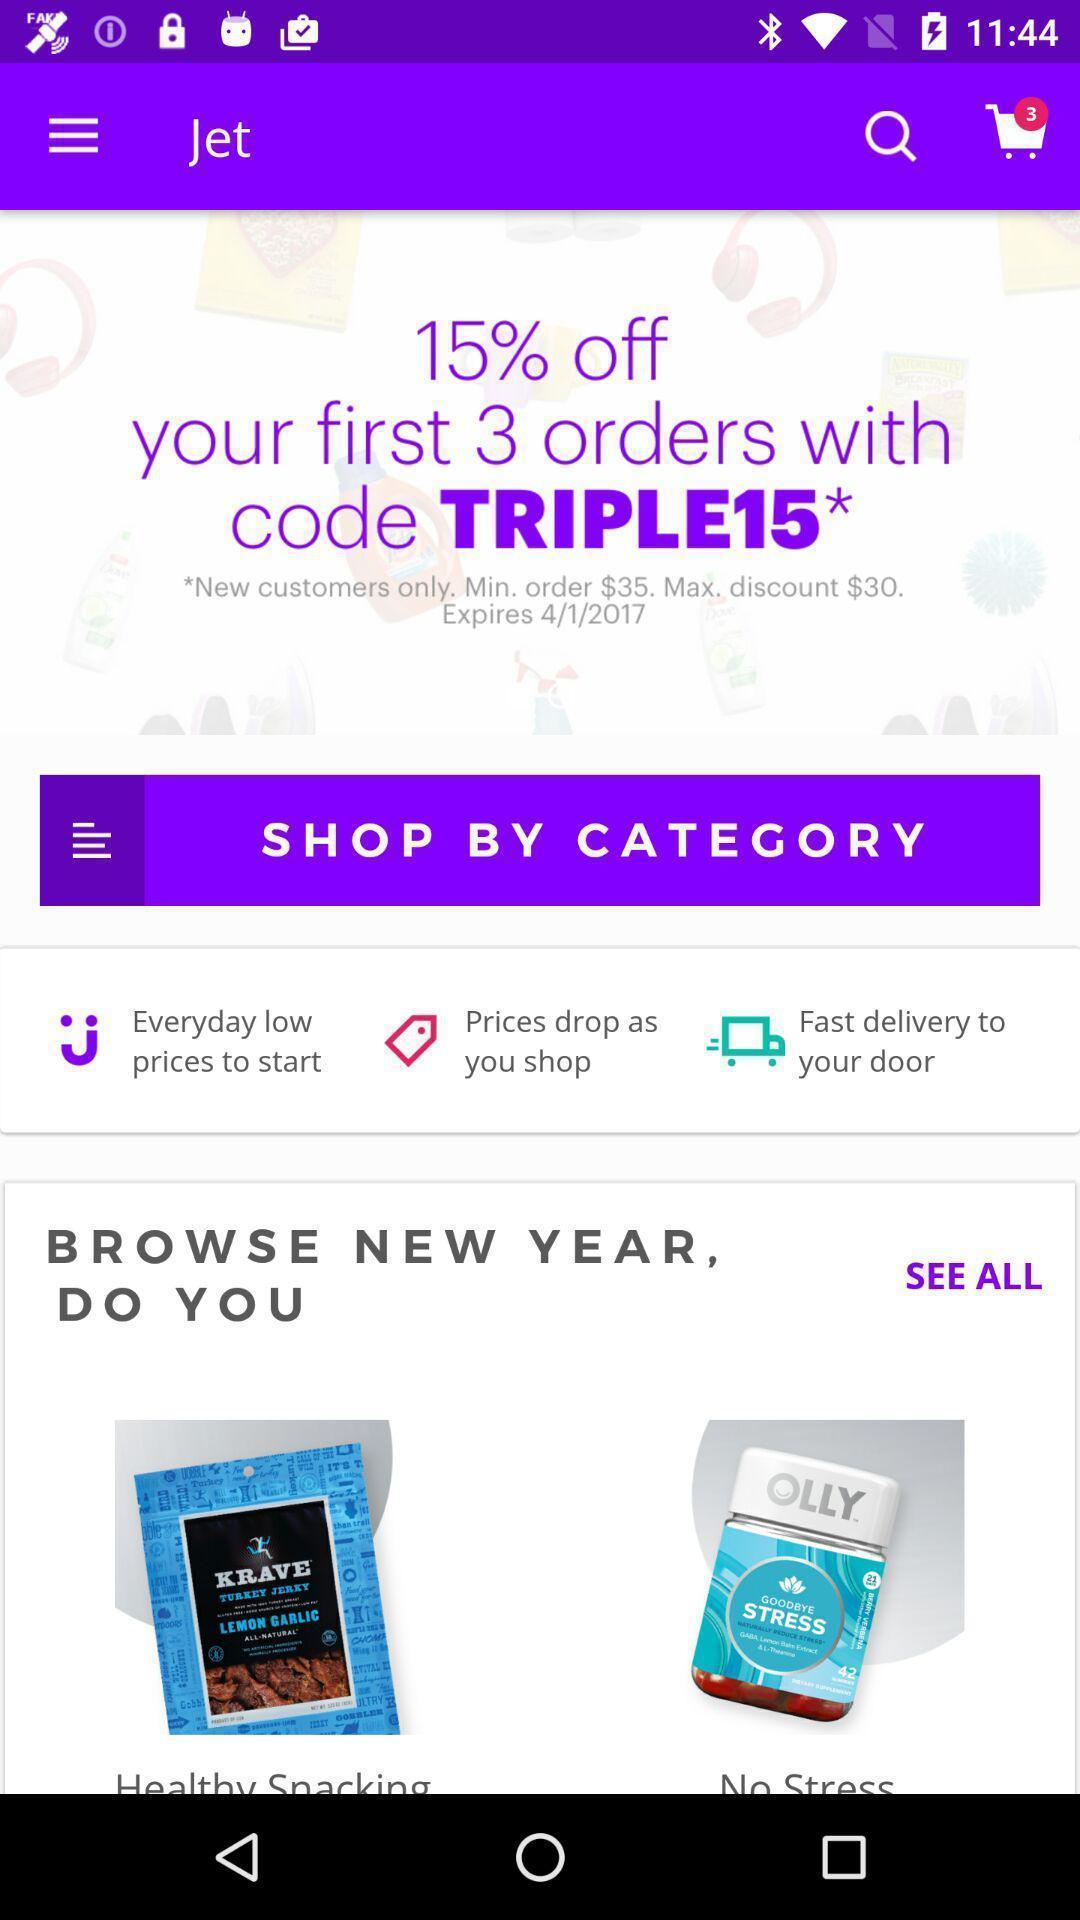Summarize the information in this screenshot. Welcome page shows to shop through category. 